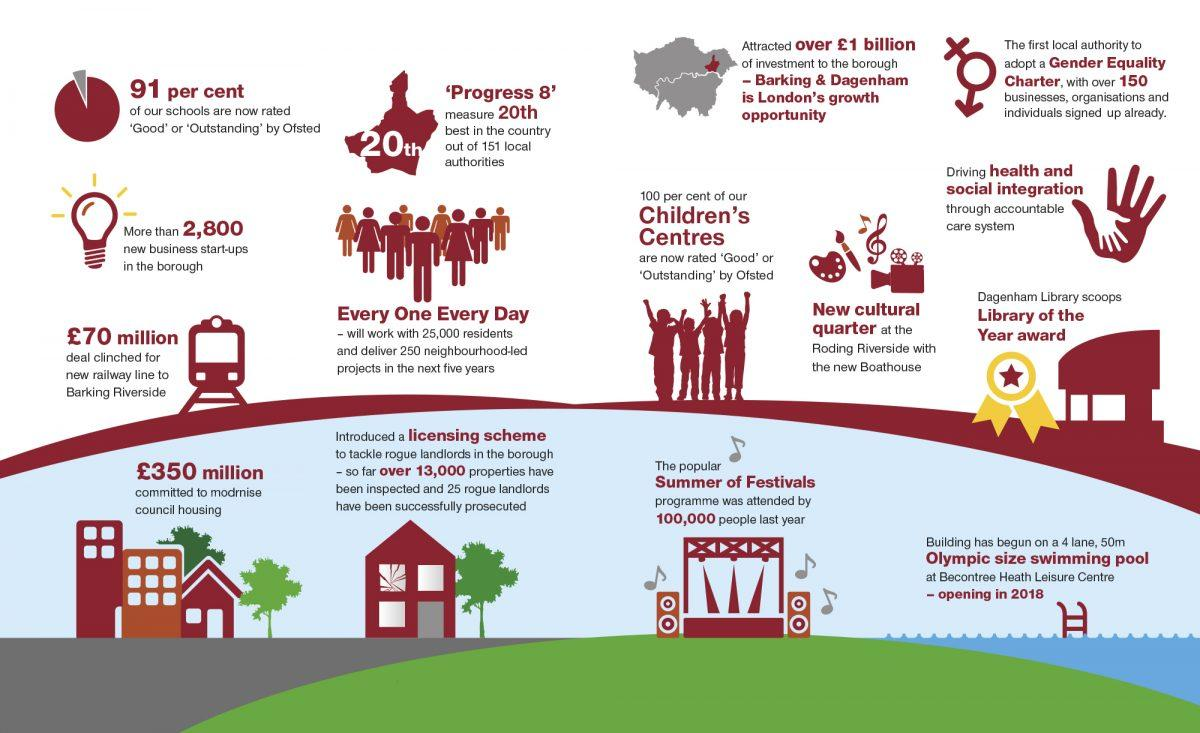Mention a couple of crucial points in this snapshot. The amount of 350 million pounds has been committed to modernize council housing. The attendance of the summer of festivals was approximately 100,000. A significant percentage of schools in the UK are not rated as good or outstanding by Ofsted. What was initiated to tackle rogue landlords? A licensing scheme, intended to protect tenants from unscrupulous property owners. The value of the railway line deal clinched by Barking Riverside was 70 million pounds. 